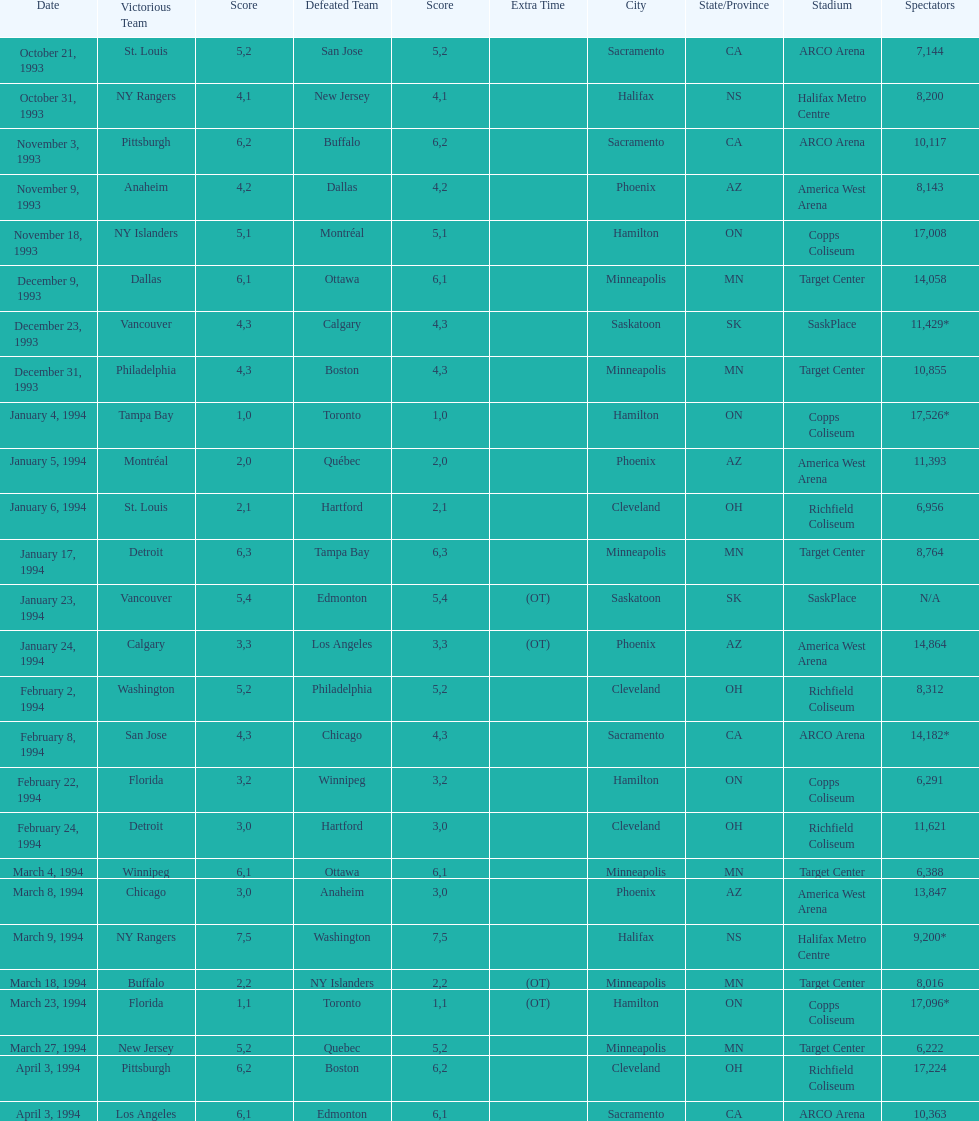Who won the game the day before the january 5, 1994 game? Tampa Bay. 